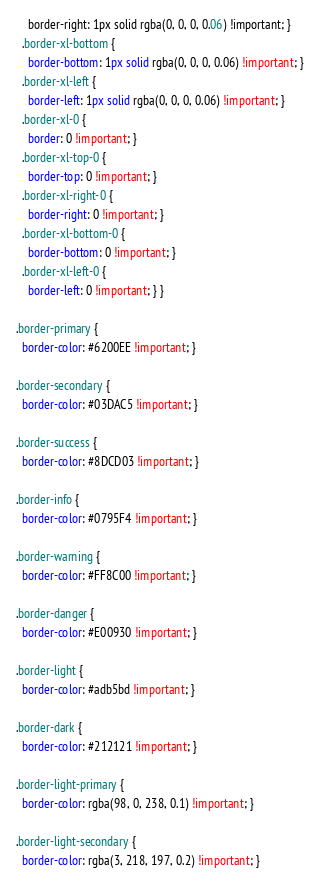<code> <loc_0><loc_0><loc_500><loc_500><_CSS_>    border-right: 1px solid rgba(0, 0, 0, 0.06) !important; }
  .border-xl-bottom {
    border-bottom: 1px solid rgba(0, 0, 0, 0.06) !important; }
  .border-xl-left {
    border-left: 1px solid rgba(0, 0, 0, 0.06) !important; }
  .border-xl-0 {
    border: 0 !important; }
  .border-xl-top-0 {
    border-top: 0 !important; }
  .border-xl-right-0 {
    border-right: 0 !important; }
  .border-xl-bottom-0 {
    border-bottom: 0 !important; }
  .border-xl-left-0 {
    border-left: 0 !important; } }

.border-primary {
  border-color: #6200EE !important; }

.border-secondary {
  border-color: #03DAC5 !important; }

.border-success {
  border-color: #8DCD03 !important; }

.border-info {
  border-color: #0795F4 !important; }

.border-warning {
  border-color: #FF8C00 !important; }

.border-danger {
  border-color: #E00930 !important; }

.border-light {
  border-color: #adb5bd !important; }

.border-dark {
  border-color: #212121 !important; }

.border-light-primary {
  border-color: rgba(98, 0, 238, 0.1) !important; }

.border-light-secondary {
  border-color: rgba(3, 218, 197, 0.2) !important; }
</code> 